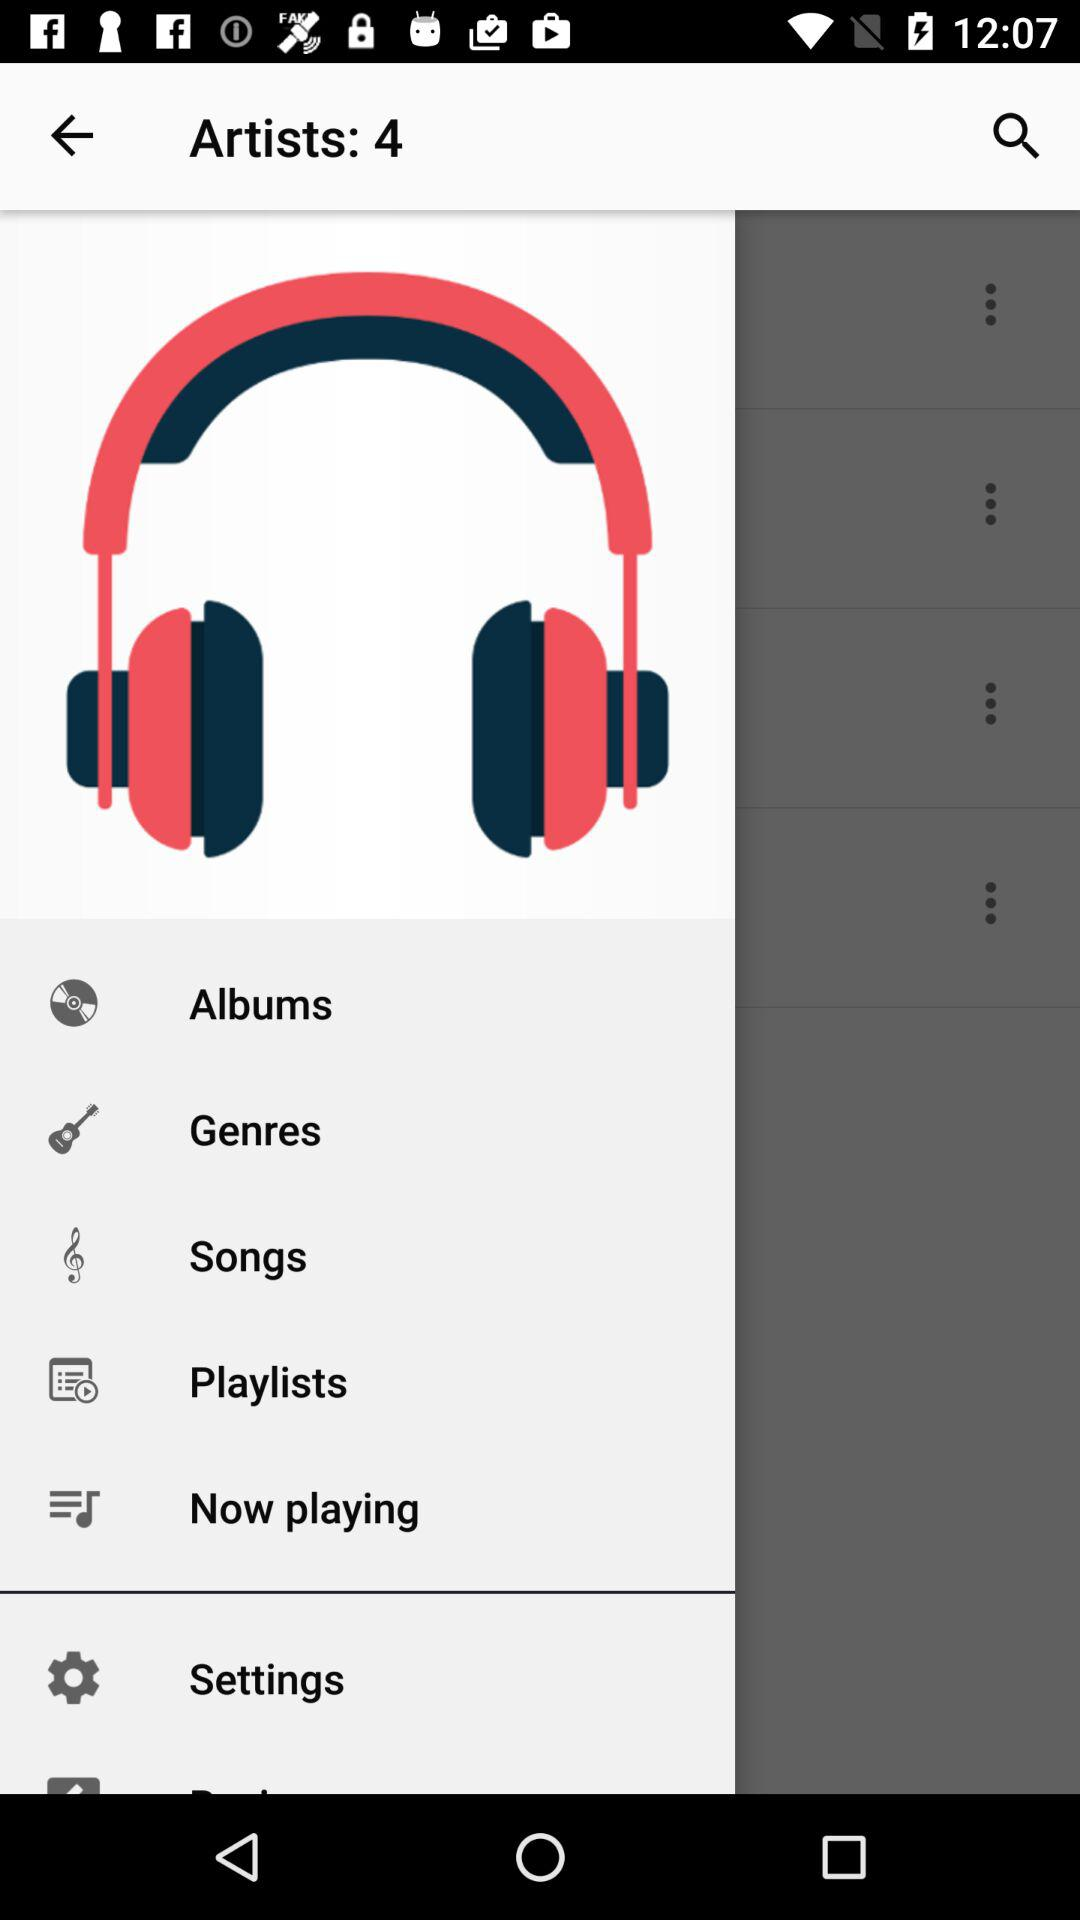What is the number of artists? There are 4 artists. 